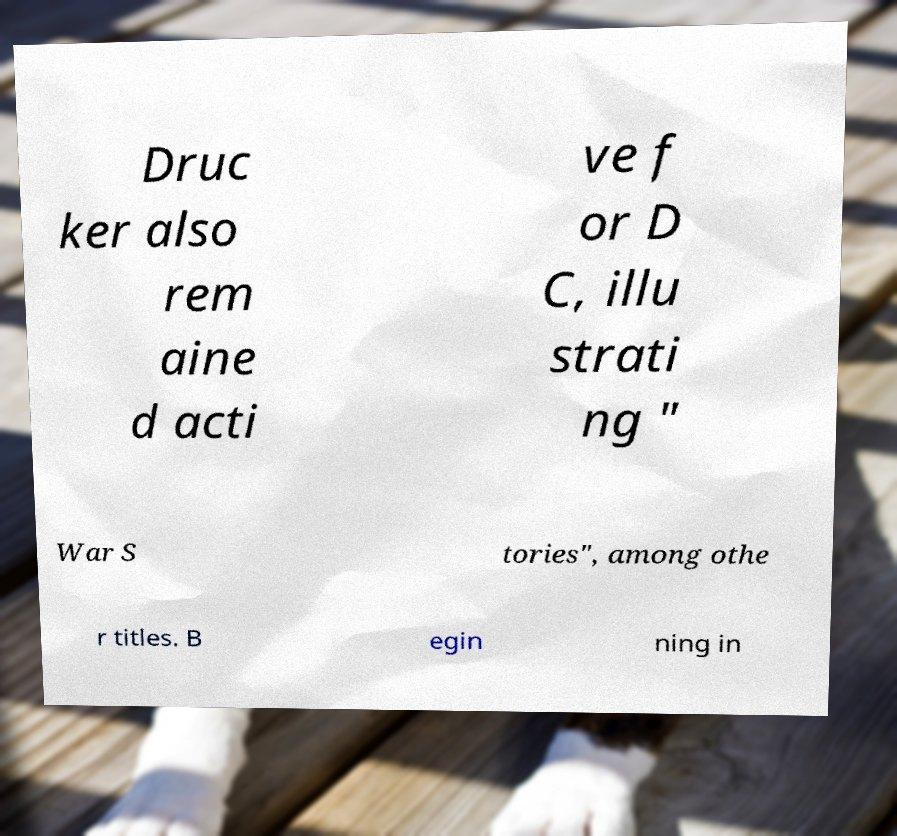For documentation purposes, I need the text within this image transcribed. Could you provide that? Druc ker also rem aine d acti ve f or D C, illu strati ng " War S tories", among othe r titles. B egin ning in 